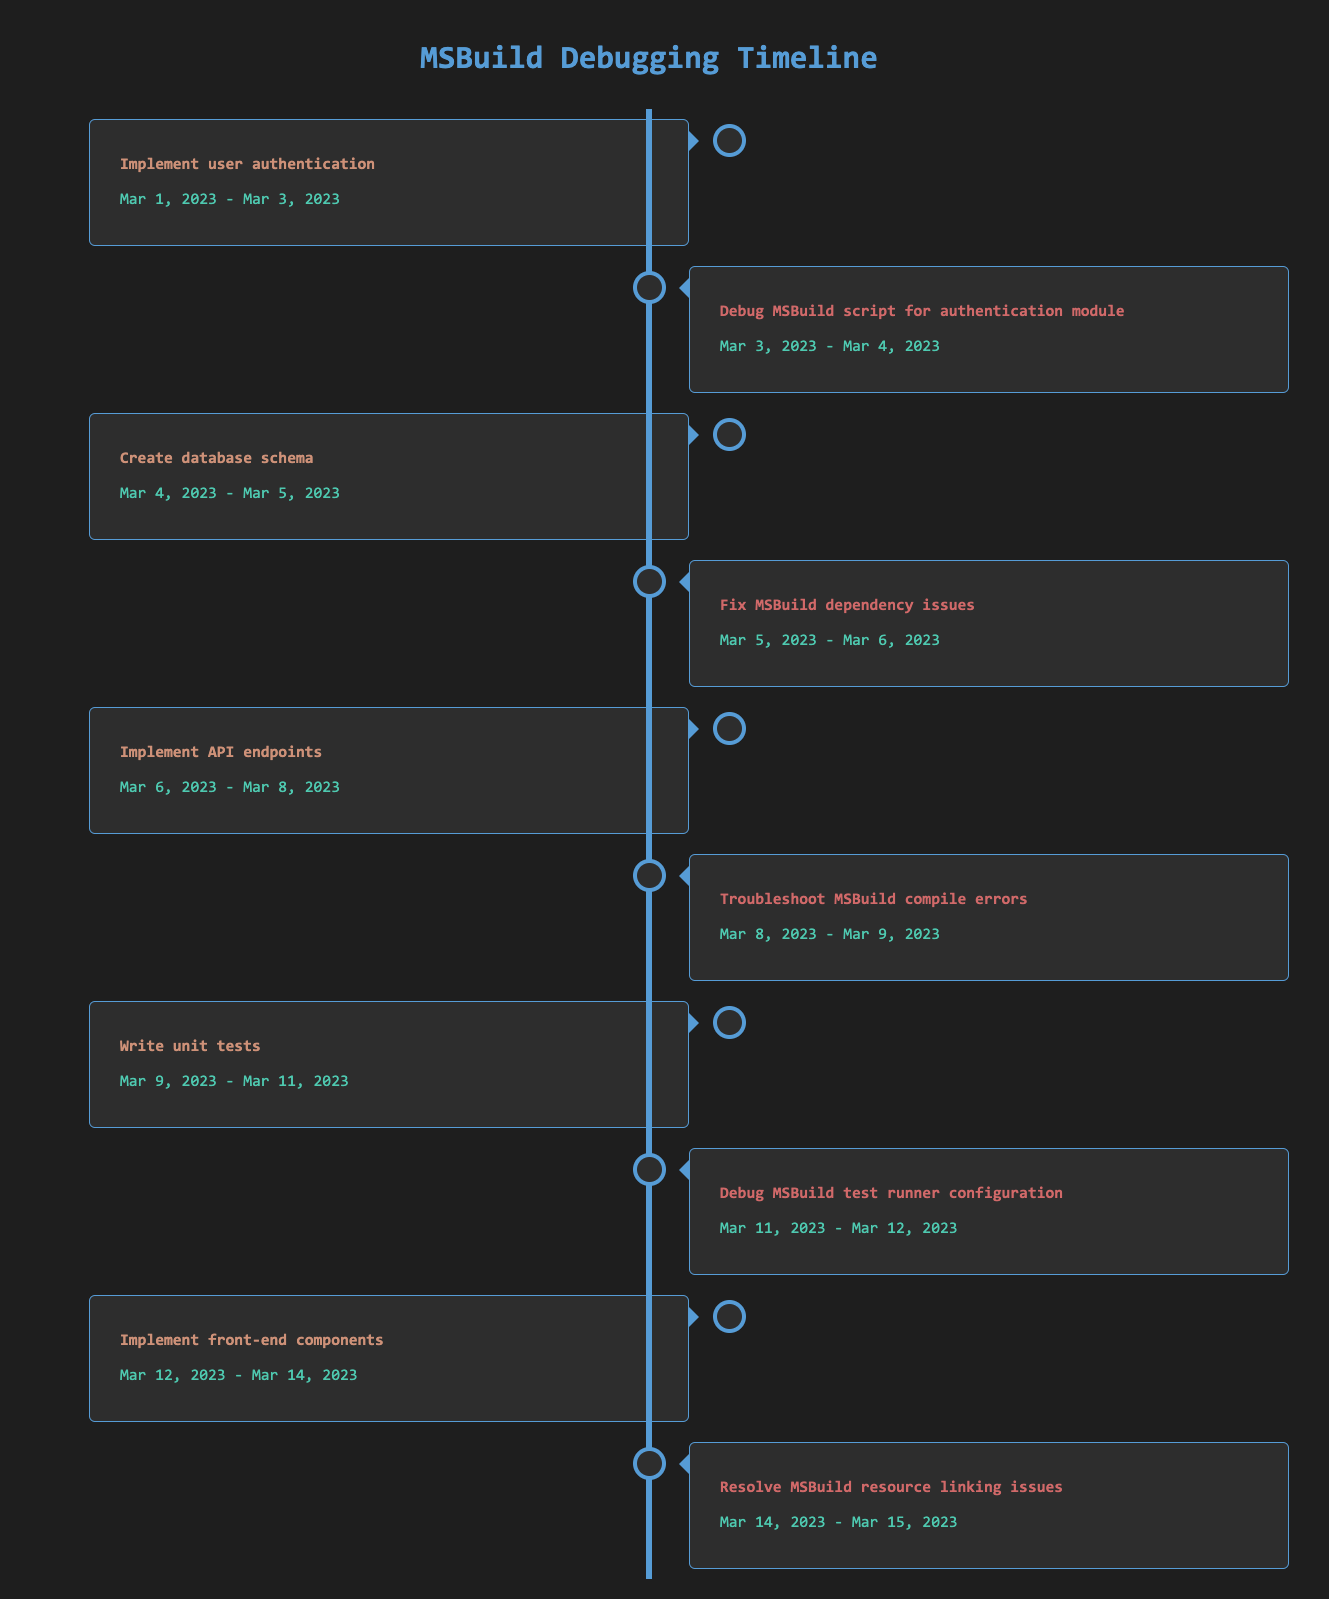What is the total time spent debugging MSBuild scripts? To find the total time spent debugging MSBuild scripts, we add up the durations of all rows associated with debugging: 1 day for debugging the authentication module (Mar 3 to Mar 4), 1 day for troubleshooting compile errors (Mar 8 to Mar 9), 1 day for debugging the test runner (Mar 11 to Mar 12), and 1 day for resolving resource linking issues (Mar 14 to Mar 15). This gives us a total of 4 days spent debugging.
Answer: 4 days What task was performed right after implementing the user authentication? The task performed right after implementing user authentication was debugging the MSBuild script for the authentication module, which occurred from Mar 3 to Mar 4.
Answer: Debug MSBuild script for authentication module Which task had the longest duration? The duration of the longest task can be checked in the table, Implement unit tests spans from Mar 9 to Mar 11, which is 2 days. While other tasks, including coding tasks and debugging, are either equal or shorter in duration.
Answer: Writing unit tests Did debugging the MSBuild script for the authentication module and fixing MSBuild dependency issues occur on consecutive days? Yes, debugging the MSBuild script for the authentication module occurred from Mar 3 to Mar 4, and fixing MSBuild dependency issues occurred from Mar 5 to Mar 6. Thus, both tasks occurred on consecutive days without gaps.
Answer: Yes What fraction of the tasks are related to debugging MSBuild? There are 4 debugging tasks out of 10 total tasks. To get the fraction, we calculate the number of MSBuild-related tasks (4) divided by the total number of tasks (10), giving us the fraction of 4/10 = 2/5.
Answer: 2/5 